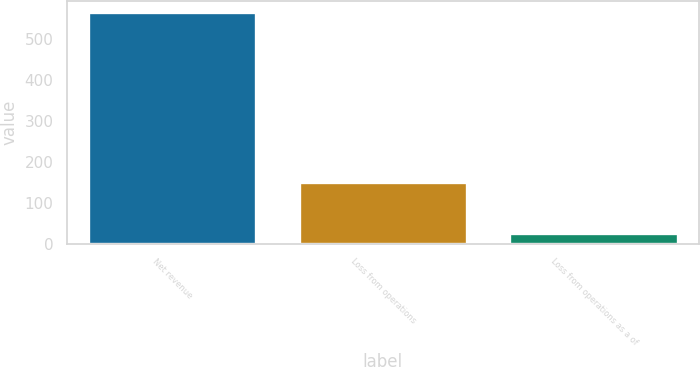<chart> <loc_0><loc_0><loc_500><loc_500><bar_chart><fcel>Net revenue<fcel>Loss from operations<fcel>Loss from operations as a of<nl><fcel>566<fcel>151<fcel>26.7<nl></chart> 